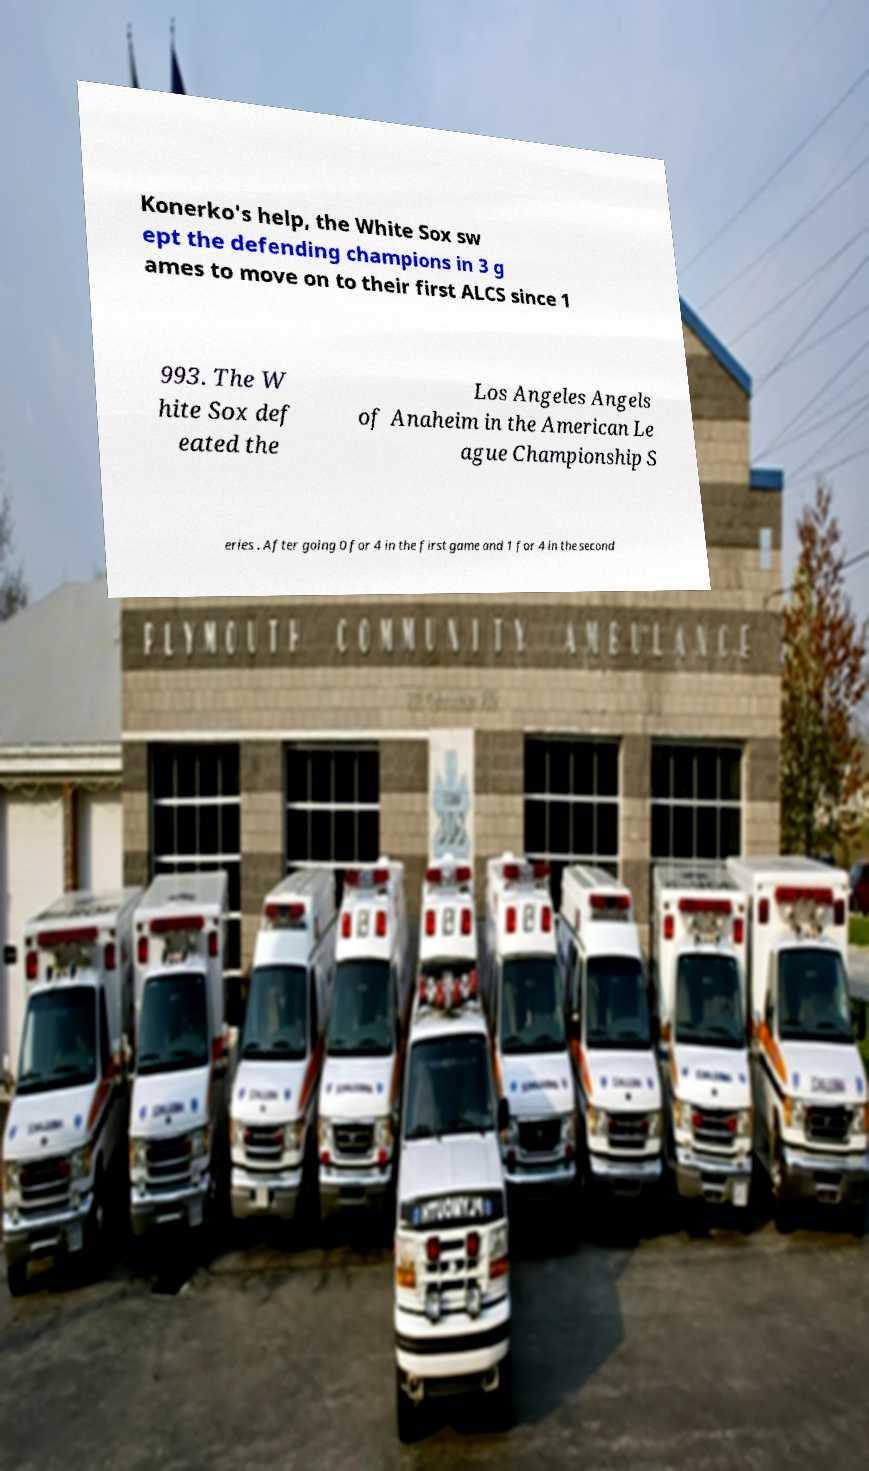Please read and relay the text visible in this image. What does it say? Konerko's help, the White Sox sw ept the defending champions in 3 g ames to move on to their first ALCS since 1 993. The W hite Sox def eated the Los Angeles Angels of Anaheim in the American Le ague Championship S eries . After going 0 for 4 in the first game and 1 for 4 in the second 